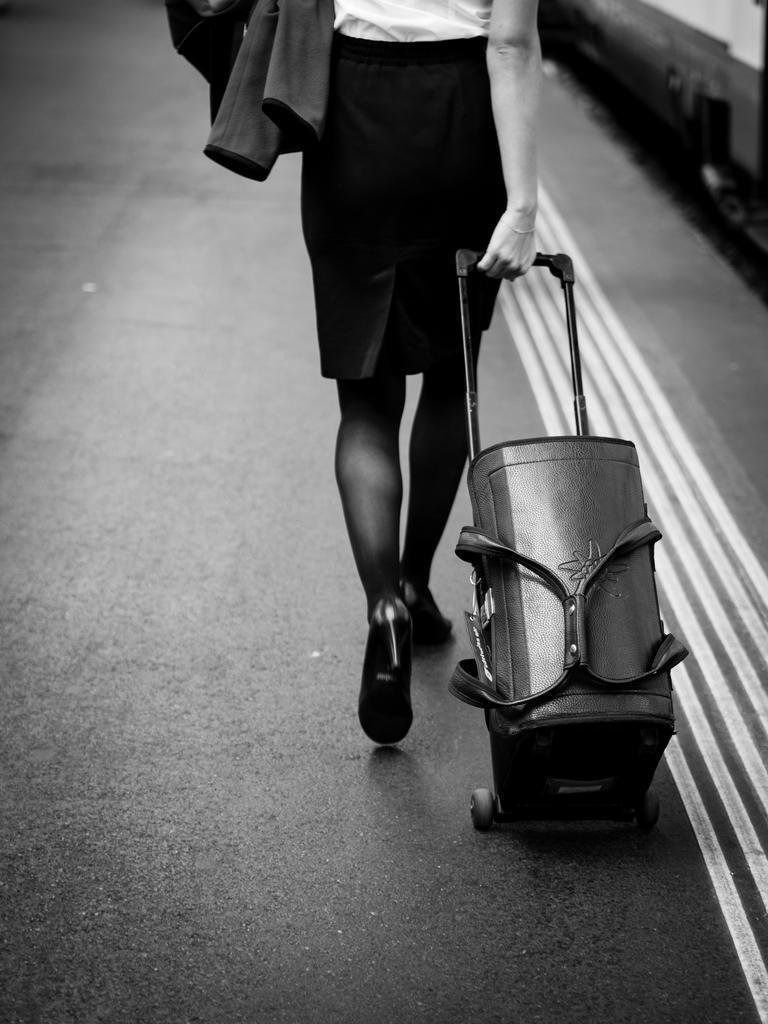Where was the image taken? The image was taken on a road. Who is present in the image? There is a woman in the image. What is the woman carrying in one hand? The woman is carrying a luggage bag in one hand. What is the woman holding in the other hand? The woman is holding a jacket in the other hand. What type of fruit is hanging from the stem in the image? There is no fruit or stem present in the image. 